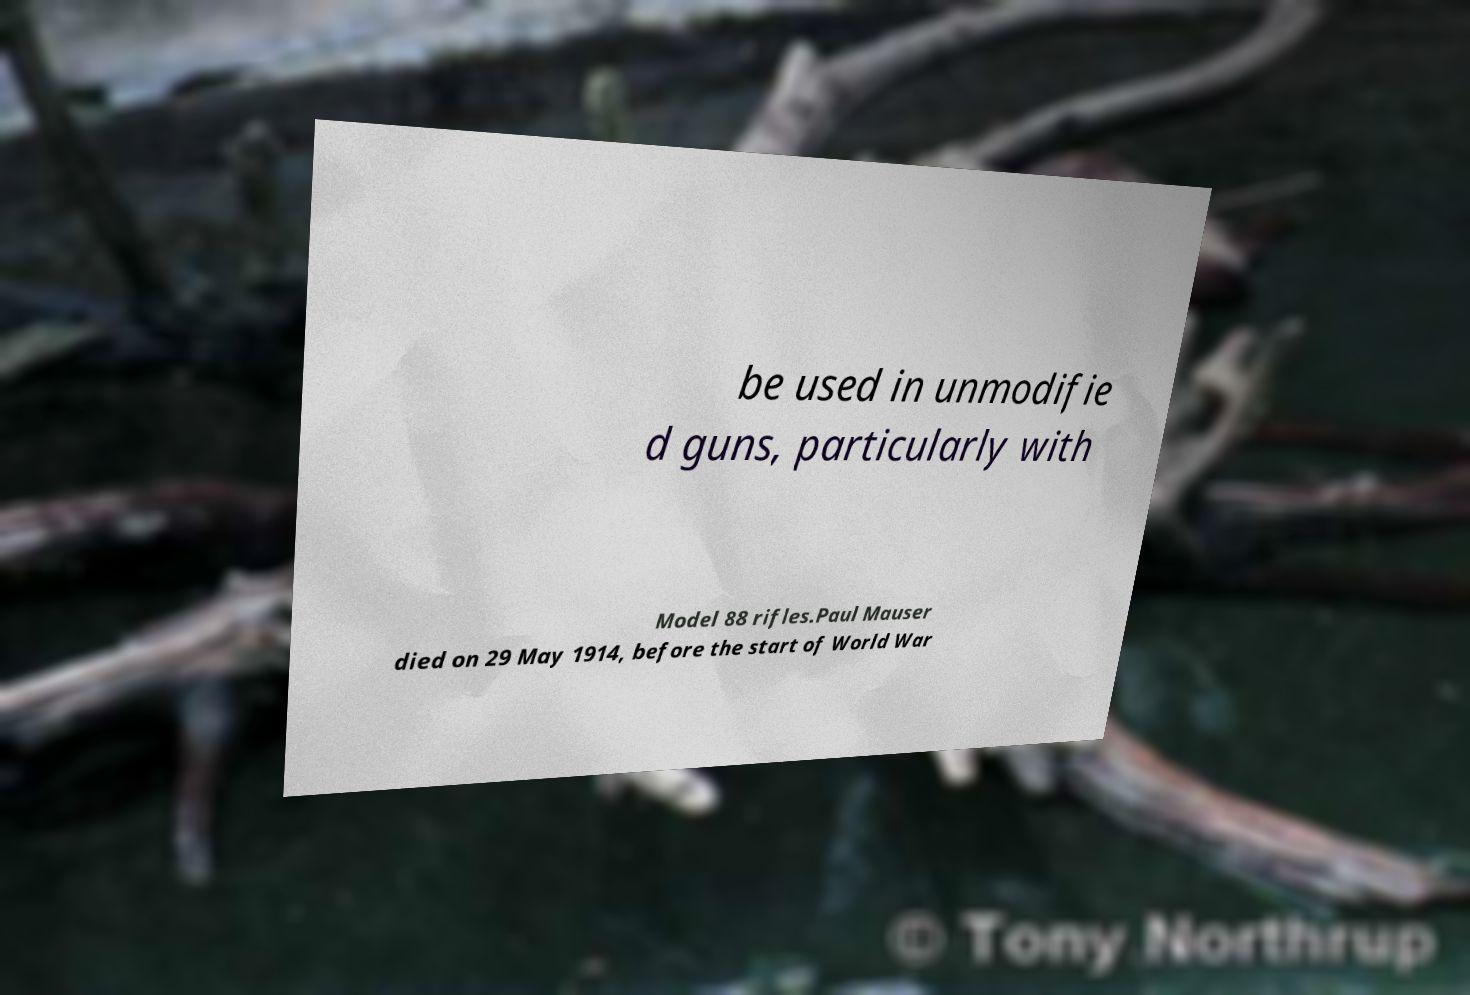Could you extract and type out the text from this image? be used in unmodifie d guns, particularly with Model 88 rifles.Paul Mauser died on 29 May 1914, before the start of World War 